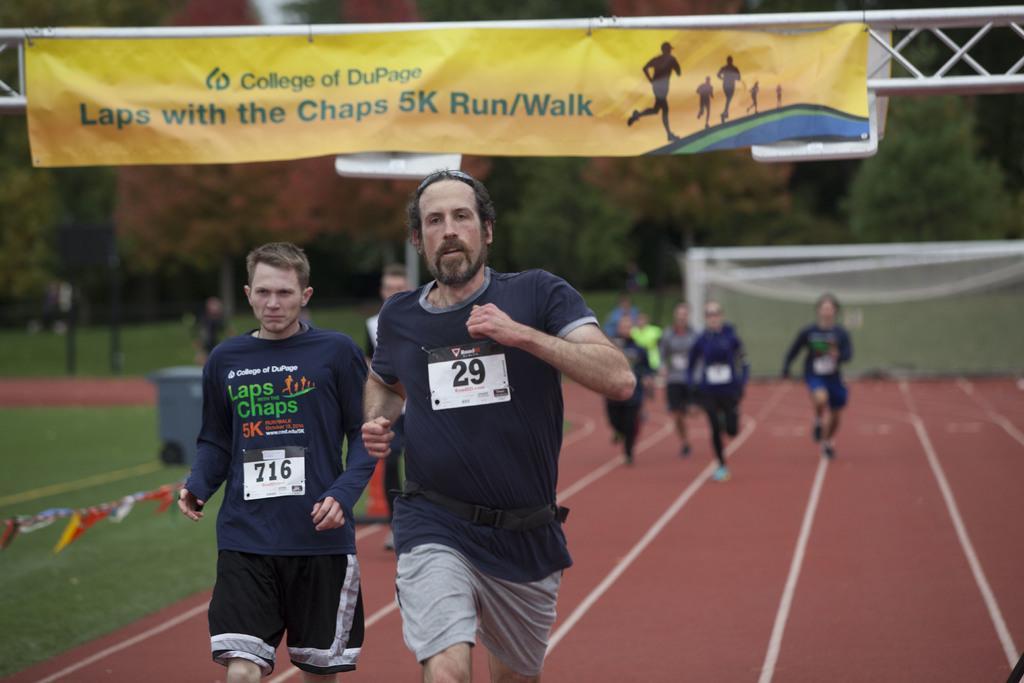Please provide a concise description of this image. In the foreground of this image, there are persons running on the ground. In the background, there are persons running on the ground, grass, dustbin, trees and a banner on the top. 